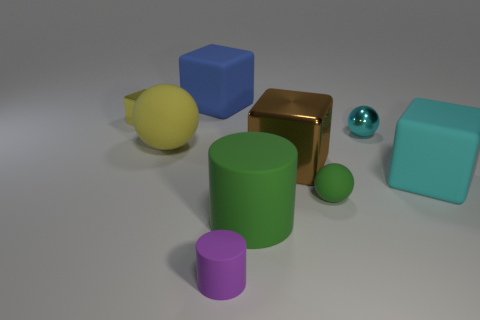What is the shape of the object that is the same color as the large ball?
Provide a succinct answer. Cube. Does the big sphere have the same material as the cyan block?
Your answer should be compact. Yes. Is there anything else that is the same material as the big blue cube?
Make the answer very short. Yes. There is a brown thing that is the same shape as the blue rubber object; what is its material?
Your response must be concise. Metal. Are there fewer yellow rubber balls in front of the large yellow matte sphere than tiny matte things?
Offer a very short reply. Yes. There is a tiny green matte ball; how many rubber objects are in front of it?
Give a very brief answer. 2. Do the rubber object that is behind the yellow metal block and the cyan object that is left of the cyan cube have the same shape?
Offer a terse response. No. What is the shape of the big matte object that is on the left side of the large metal block and on the right side of the big blue object?
Offer a very short reply. Cylinder. What size is the blue thing that is made of the same material as the small green object?
Give a very brief answer. Large. Is the number of big red spheres less than the number of brown things?
Keep it short and to the point. Yes. 